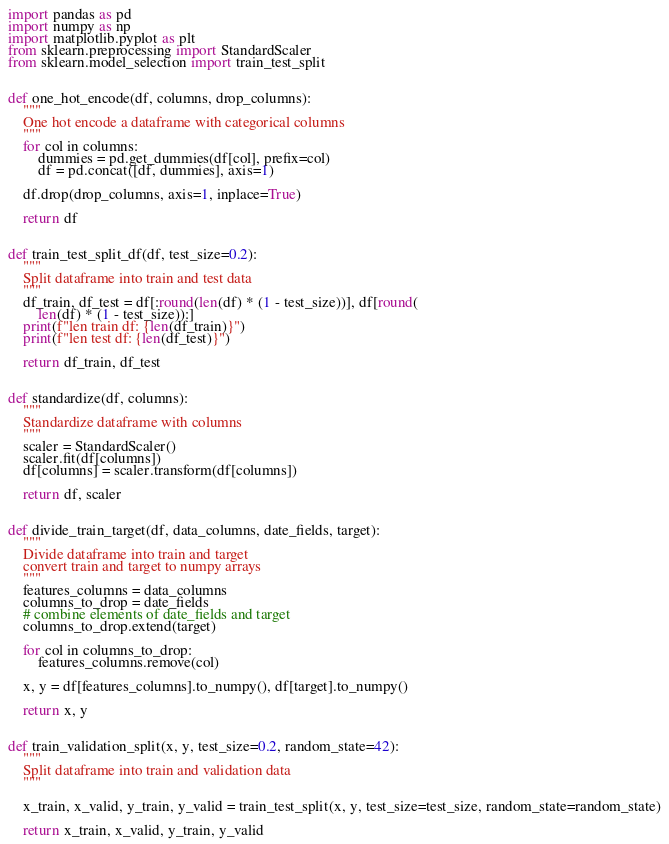Convert code to text. <code><loc_0><loc_0><loc_500><loc_500><_Python_>import pandas as pd
import numpy as np
import matplotlib.pyplot as plt
from sklearn.preprocessing import StandardScaler
from sklearn.model_selection import train_test_split


def one_hot_encode(df, columns, drop_columns):
    """
    One hot encode a dataframe with categorical columns
    """
    for col in columns:
        dummies = pd.get_dummies(df[col], prefix=col)
        df = pd.concat([df, dummies], axis=1)

    df.drop(drop_columns, axis=1, inplace=True)

    return df


def train_test_split_df(df, test_size=0.2):
    """
    Split dataframe into train and test data
    """
    df_train, df_test = df[:round(len(df) * (1 - test_size))], df[round(
        len(df) * (1 - test_size)):]
    print(f"len train df: {len(df_train)}")
    print(f"len test df: {len(df_test)}")

    return df_train, df_test


def standardize(df, columns):
    """
    Standardize dataframe with columns
    """
    scaler = StandardScaler()
    scaler.fit(df[columns])
    df[columns] = scaler.transform(df[columns])

    return df, scaler


def divide_train_target(df, data_columns, date_fields, target):
    """
    Divide dataframe into train and target
    convert train and target to numpy arrays
    """
    features_columns = data_columns
    columns_to_drop = date_fields
    # combine elements of date_fields and target
    columns_to_drop.extend(target)

    for col in columns_to_drop:
        features_columns.remove(col)

    x, y = df[features_columns].to_numpy(), df[target].to_numpy()

    return x, y


def train_validation_split(x, y, test_size=0.2, random_state=42):
    """
    Split dataframe into train and validation data
    """

    x_train, x_valid, y_train, y_valid = train_test_split(x, y, test_size=test_size, random_state=random_state)

    return x_train, x_valid, y_train, y_valid</code> 